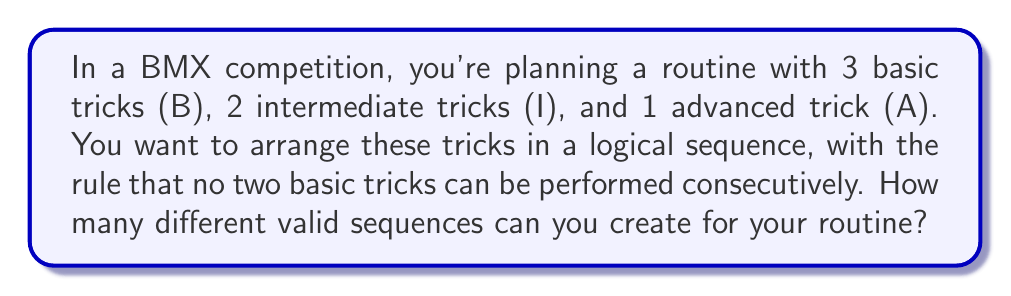Give your solution to this math problem. Let's approach this step-by-step:

1) First, we need to understand the constraints:
   - We have 3 B, 2 I, and 1 A trick
   - No two B tricks can be adjacent

2) To satisfy the "no adjacent B" rule, we need to place the non-B tricks (I and A) between the B tricks.

3) Let's represent the sequence as: _ B _ B _ B _
   Where _ represents a spot that can be filled by either I or A

4) We have 4 spots to fill with 3 non-B tricks (2 I and 1 A)

5) This is equivalent to choosing 3 positions out of 4 to place our non-B tricks, which can be calculated using the combination formula:

   $$\binom{4}{3} = \frac{4!}{3!(4-3)!} = \frac{4 \cdot 3 \cdot 2 \cdot 1}{(3 \cdot 2 \cdot 1)(1)} = 4$$

6) For each of these 4 ways to place the non-B tricks, we need to arrange the 2 I and 1 A trick. This can be done in 3! = 6 ways.

7) Therefore, the total number of valid sequences is:

   $$4 \cdot 6 = 24$$

8) However, we're not done yet. Remember that the B tricks are indistinguishable from each other. The same applies to the I tricks. Only the A trick is unique.

9) To account for this, we need to divide our result by the number of ways to arrange the B tricks (3!) and the I tricks (2!):

   $$\frac{24}{3! \cdot 2!} = \frac{24}{6 \cdot 2} = 2$$

Thus, there are 2 distinct valid sequences for your BMX routine.
Answer: 2 distinct valid sequences 